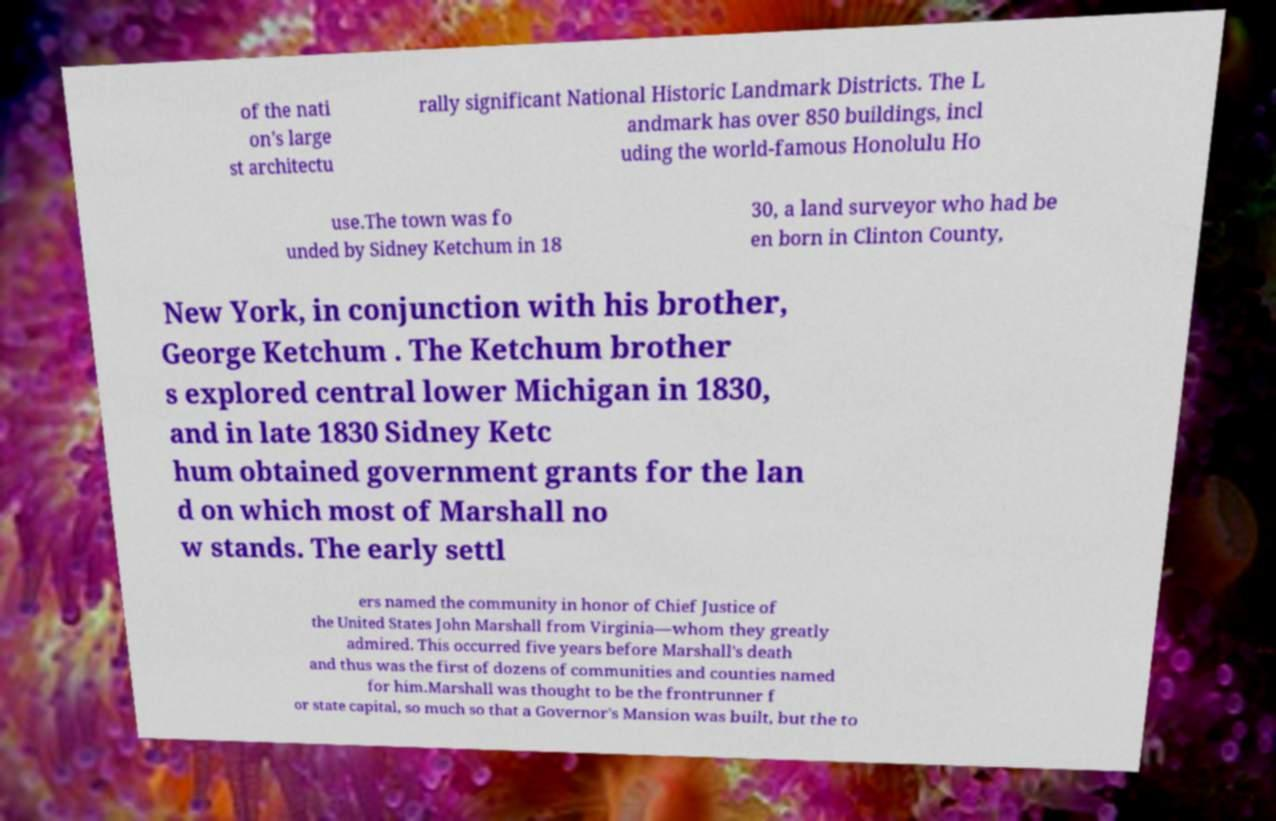Could you assist in decoding the text presented in this image and type it out clearly? of the nati on's large st architectu rally significant National Historic Landmark Districts. The L andmark has over 850 buildings, incl uding the world-famous Honolulu Ho use.The town was fo unded by Sidney Ketchum in 18 30, a land surveyor who had be en born in Clinton County, New York, in conjunction with his brother, George Ketchum . The Ketchum brother s explored central lower Michigan in 1830, and in late 1830 Sidney Ketc hum obtained government grants for the lan d on which most of Marshall no w stands. The early settl ers named the community in honor of Chief Justice of the United States John Marshall from Virginia—whom they greatly admired. This occurred five years before Marshall's death and thus was the first of dozens of communities and counties named for him.Marshall was thought to be the frontrunner f or state capital, so much so that a Governor's Mansion was built, but the to 